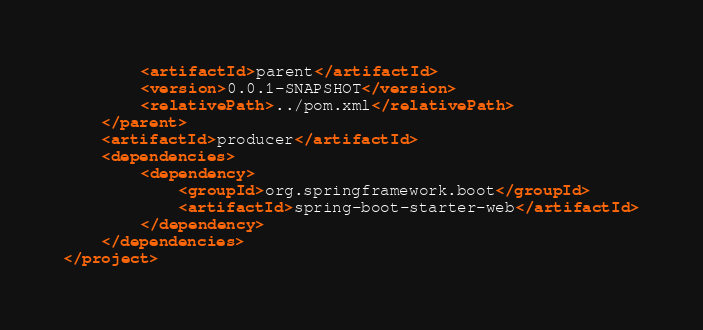<code> <loc_0><loc_0><loc_500><loc_500><_XML_>        <artifactId>parent</artifactId>
        <version>0.0.1-SNAPSHOT</version>
        <relativePath>../pom.xml</relativePath>
    </parent>
    <artifactId>producer</artifactId>
    <dependencies>
        <dependency>
            <groupId>org.springframework.boot</groupId>
            <artifactId>spring-boot-starter-web</artifactId>
        </dependency>
    </dependencies>
</project>
</code> 